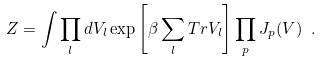<formula> <loc_0><loc_0><loc_500><loc_500>Z = \int \prod _ { l } d V _ { l } \exp \left [ \beta \sum _ { l } { T r } V _ { l } \right ] \prod _ { p } J _ { p } ( V ) \ .</formula> 